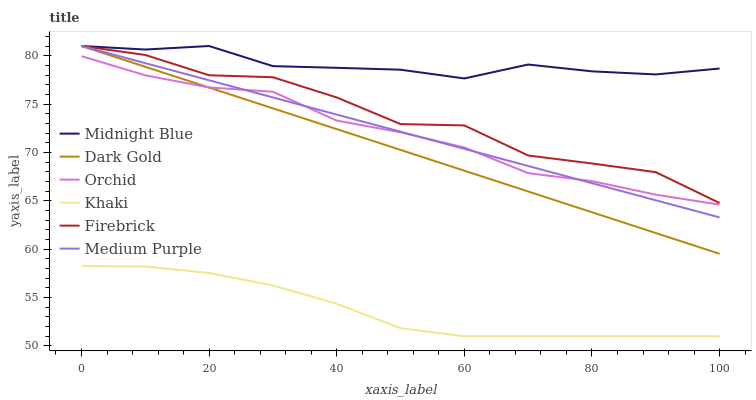Does Khaki have the minimum area under the curve?
Answer yes or no. Yes. Does Midnight Blue have the maximum area under the curve?
Answer yes or no. Yes. Does Dark Gold have the minimum area under the curve?
Answer yes or no. No. Does Dark Gold have the maximum area under the curve?
Answer yes or no. No. Is Dark Gold the smoothest?
Answer yes or no. Yes. Is Firebrick the roughest?
Answer yes or no. Yes. Is Midnight Blue the smoothest?
Answer yes or no. No. Is Midnight Blue the roughest?
Answer yes or no. No. Does Khaki have the lowest value?
Answer yes or no. Yes. Does Dark Gold have the lowest value?
Answer yes or no. No. Does Medium Purple have the highest value?
Answer yes or no. Yes. Does Orchid have the highest value?
Answer yes or no. No. Is Khaki less than Firebrick?
Answer yes or no. Yes. Is Firebrick greater than Khaki?
Answer yes or no. Yes. Does Firebrick intersect Medium Purple?
Answer yes or no. Yes. Is Firebrick less than Medium Purple?
Answer yes or no. No. Is Firebrick greater than Medium Purple?
Answer yes or no. No. Does Khaki intersect Firebrick?
Answer yes or no. No. 